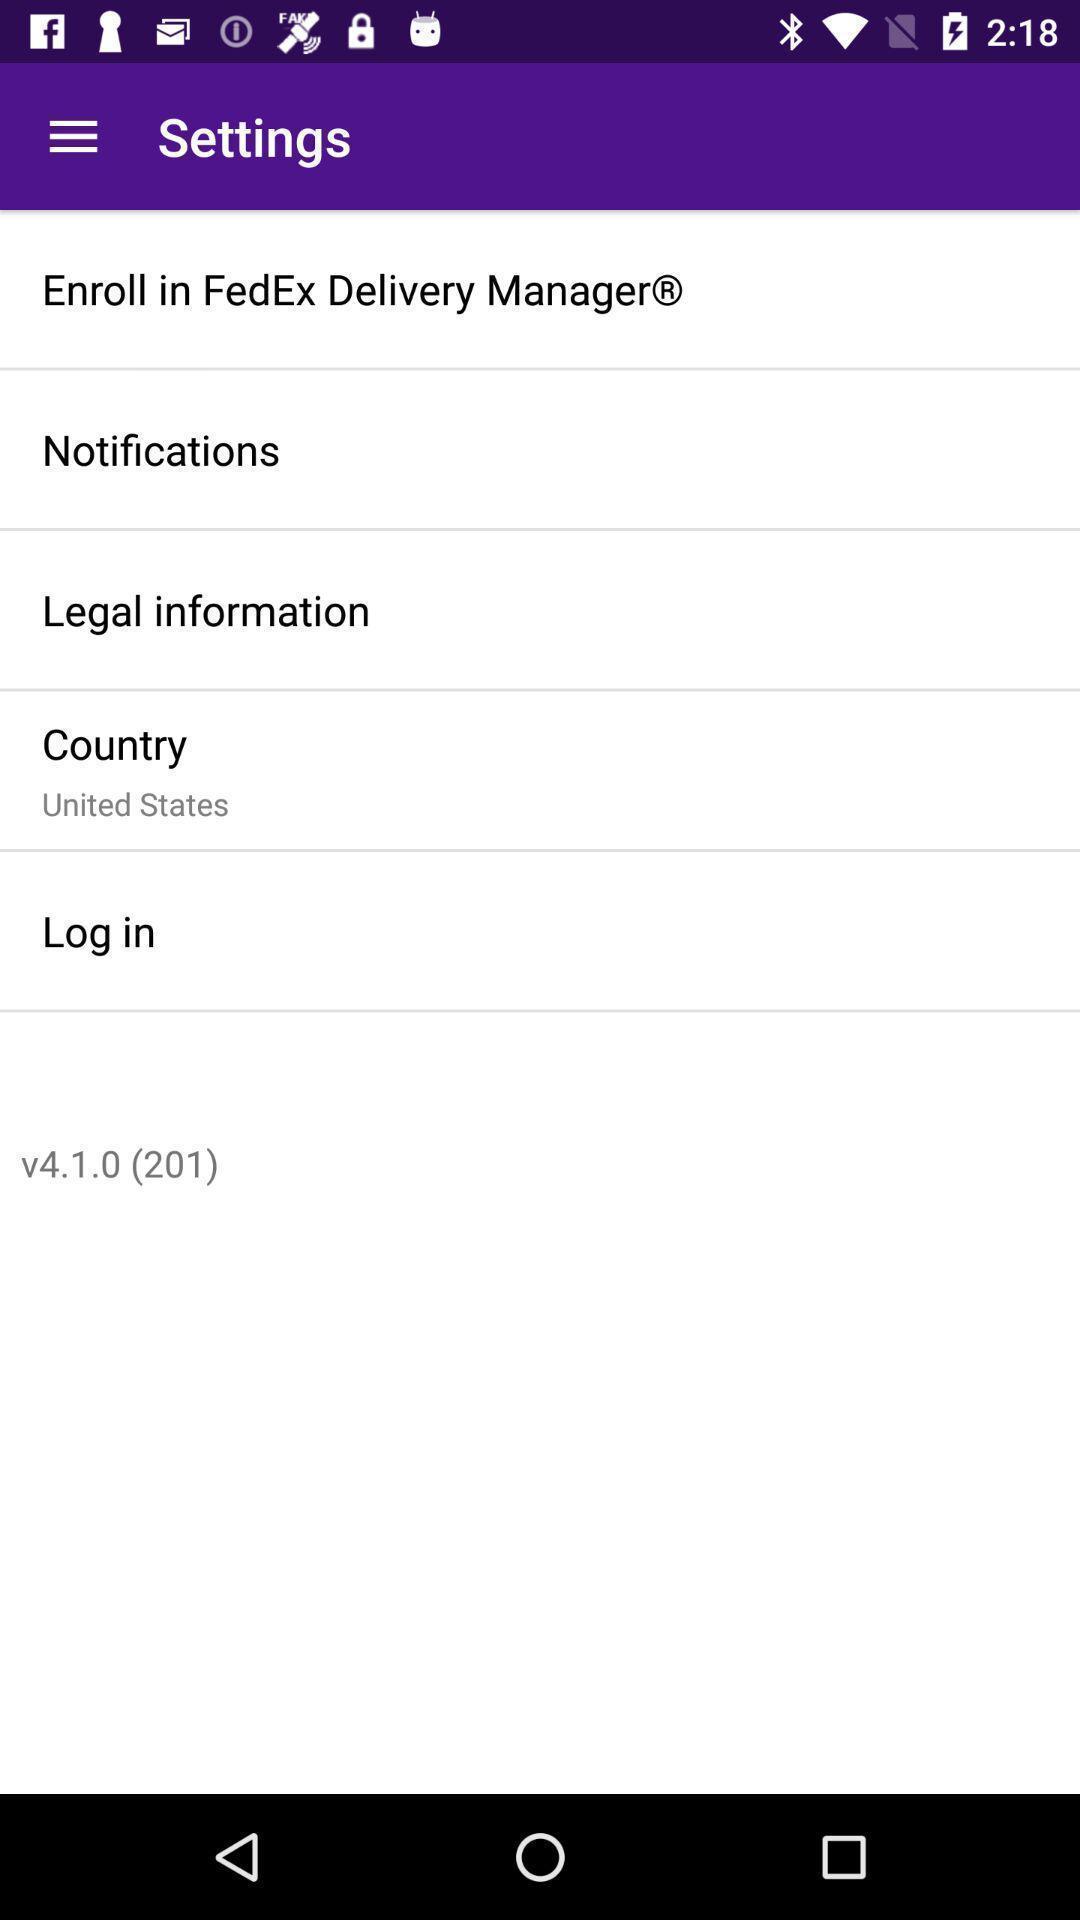Give me a narrative description of this picture. Settings page with options in the shipping app. 